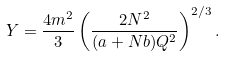Convert formula to latex. <formula><loc_0><loc_0><loc_500><loc_500>Y = \frac { 4 m ^ { 2 } } { 3 } \left ( \frac { 2 N ^ { 2 } } { ( a + N b ) Q ^ { 2 } } \right ) ^ { 2 / 3 } .</formula> 